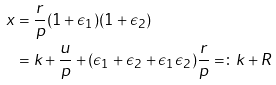<formula> <loc_0><loc_0><loc_500><loc_500>x & = \frac { r } { p } ( 1 + \epsilon _ { 1 } ) ( 1 + \epsilon _ { 2 } ) \\ & = k + \frac { u } { p } + ( \epsilon _ { 1 } + \epsilon _ { 2 } + \epsilon _ { 1 } \epsilon _ { 2 } ) \frac { r } { p } = \colon k + R</formula> 